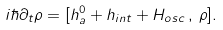Convert formula to latex. <formula><loc_0><loc_0><loc_500><loc_500>i \hbar { \partial } _ { t } \rho = [ h _ { a } ^ { 0 } + h _ { i n t } + H _ { o s c } \, , \, \rho ] .</formula> 